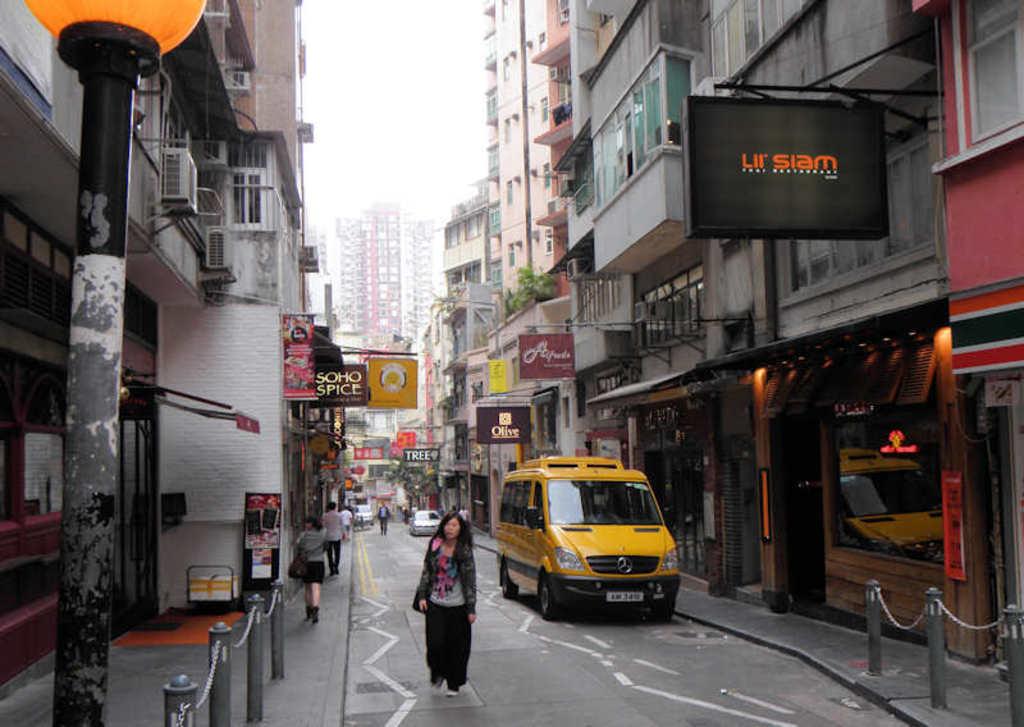What is the store on the right?
Keep it short and to the point. Lil siam. What is the black sign?
Your answer should be very brief. Lil siam. 